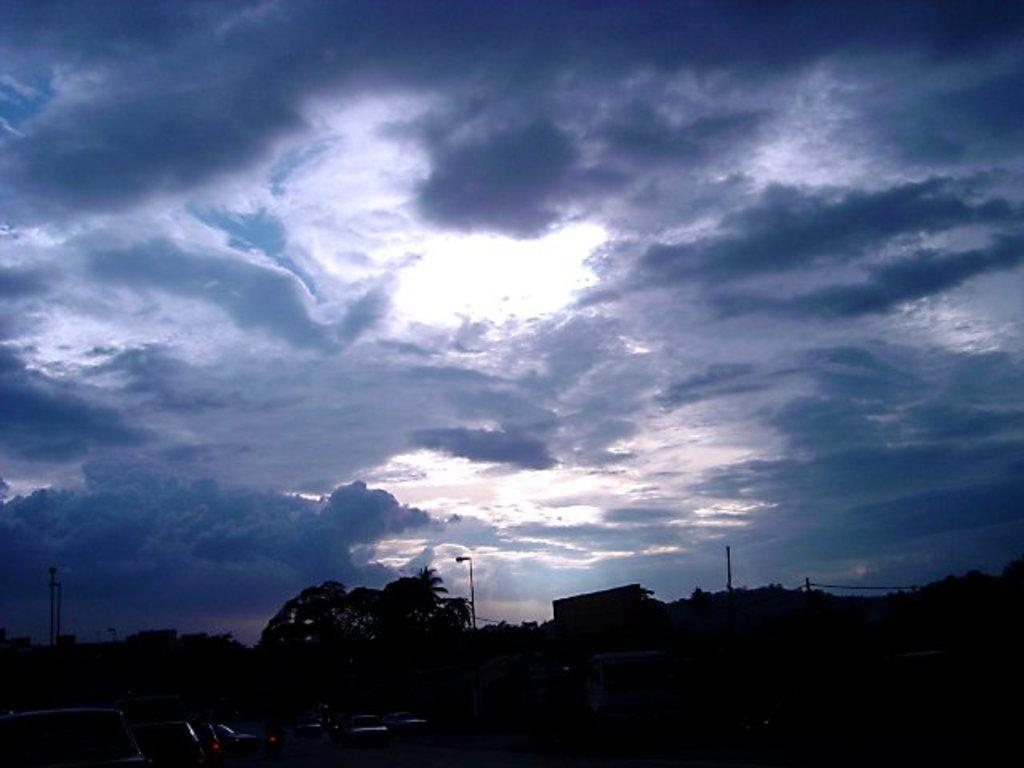What is the condition of the sky in the image? The sky is cloudy in the image. What types of objects can be seen in the image? There are vehicles, trees, and light poles in the image. What type of horn can be heard in the image? There is no sound present in the image, so it is not possible to determine if a horn can be heard. 